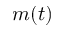<formula> <loc_0><loc_0><loc_500><loc_500>m ( t )</formula> 